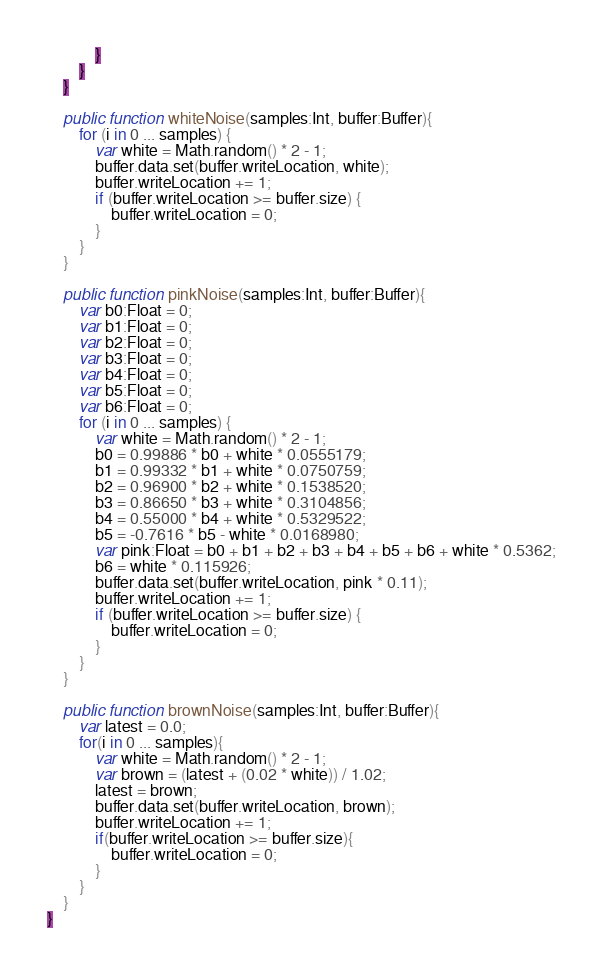Convert code to text. <code><loc_0><loc_0><loc_500><loc_500><_Haxe_>			}
		}
	}

	public function whiteNoise(samples:Int, buffer:Buffer){
		for (i in 0 ... samples) {
			var white = Math.random() * 2 - 1;
			buffer.data.set(buffer.writeLocation, white);
			buffer.writeLocation += 1;
			if (buffer.writeLocation >= buffer.size) {
				buffer.writeLocation = 0;
			}
		}
	}

	public function pinkNoise(samples:Int, buffer:Buffer){
		var b0:Float = 0;
		var b1:Float = 0;
		var b2:Float = 0;
		var b3:Float = 0;
		var b4:Float = 0;
		var b5:Float = 0;
		var b6:Float = 0;
		for (i in 0 ... samples) {
			var white = Math.random() * 2 - 1;
			b0 = 0.99886 * b0 + white * 0.0555179;
			b1 = 0.99332 * b1 + white * 0.0750759;
			b2 = 0.96900 * b2 + white * 0.1538520;
			b3 = 0.86650 * b3 + white * 0.3104856;
			b4 = 0.55000 * b4 + white * 0.5329522;
			b5 = -0.7616 * b5 - white * 0.0168980;
			var pink:Float = b0 + b1 + b2 + b3 + b4 + b5 + b6 + white * 0.5362;
			b6 = white * 0.115926;
			buffer.data.set(buffer.writeLocation, pink * 0.11);
			buffer.writeLocation += 1;
			if (buffer.writeLocation >= buffer.size) {
				buffer.writeLocation = 0;
			}
		}
	}

	public function brownNoise(samples:Int, buffer:Buffer){
		var latest = 0.0;
		for(i in 0 ... samples){
			var white = Math.random() * 2 - 1;
			var brown = (latest + (0.02 * white)) / 1.02;			
			latest = brown; 
			buffer.data.set(buffer.writeLocation, brown);
			buffer.writeLocation += 1;
			if(buffer.writeLocation >= buffer.size){
				buffer.writeLocation = 0;
			}
		}
	}
}</code> 